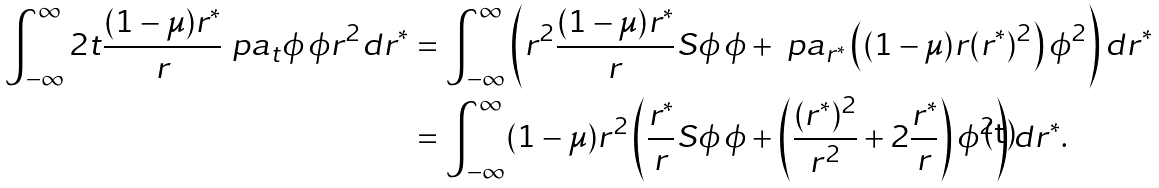<formula> <loc_0><loc_0><loc_500><loc_500>\int _ { - \infty } ^ { \infty } 2 t \frac { ( 1 - \mu ) r ^ { * } } r \ p a _ { t } \phi \, \phi r ^ { 2 } d r ^ { * } & = \int _ { - \infty } ^ { \infty } \left ( r ^ { 2 } \frac { ( 1 - \mu ) r ^ { * } } r S \phi \, \phi + \ p a _ { r ^ { * } } \left ( ( 1 - \mu ) r ( r ^ { * } ) ^ { 2 } \right ) \phi ^ { 2 } \right ) d r ^ { * } \\ & = \int _ { - \infty } ^ { \infty } ( 1 - \mu ) r ^ { 2 } \left ( \frac { r ^ { * } } r S \phi \, \phi + \left ( \frac { ( r ^ { * } ) ^ { 2 } } { r ^ { 2 } } + 2 \frac { r ^ { * } } r \right ) \phi ^ { 2 } \right ) d r ^ { * } .</formula> 